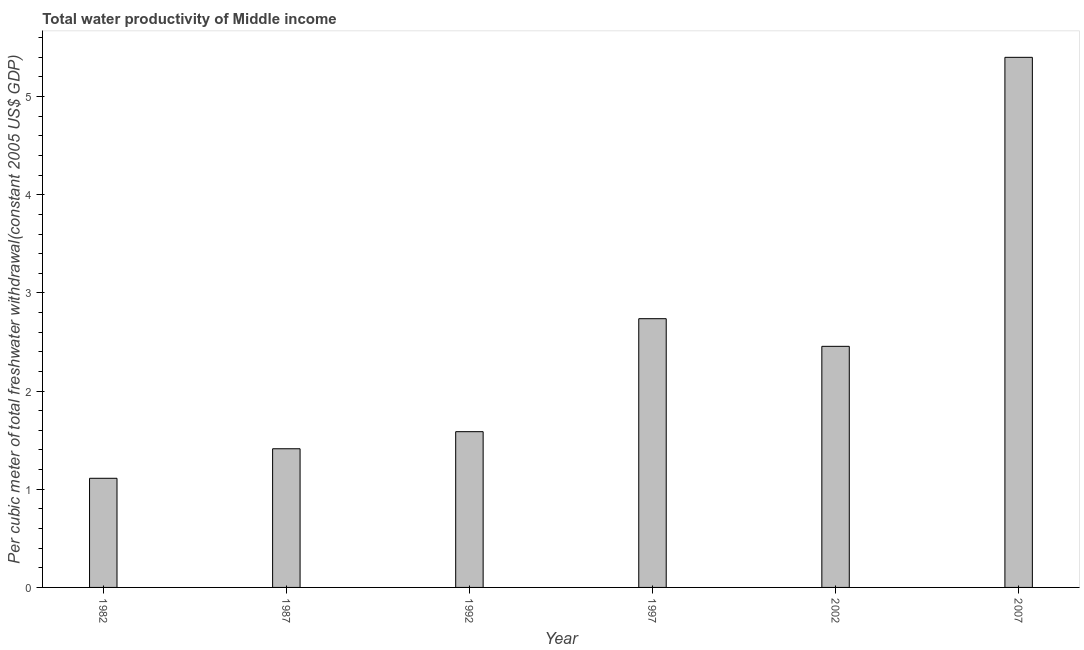Does the graph contain any zero values?
Your response must be concise. No. What is the title of the graph?
Your answer should be compact. Total water productivity of Middle income. What is the label or title of the Y-axis?
Provide a succinct answer. Per cubic meter of total freshwater withdrawal(constant 2005 US$ GDP). What is the total water productivity in 1992?
Give a very brief answer. 1.59. Across all years, what is the maximum total water productivity?
Ensure brevity in your answer.  5.4. Across all years, what is the minimum total water productivity?
Give a very brief answer. 1.11. In which year was the total water productivity maximum?
Keep it short and to the point. 2007. What is the sum of the total water productivity?
Ensure brevity in your answer.  14.7. What is the difference between the total water productivity in 1997 and 2002?
Keep it short and to the point. 0.28. What is the average total water productivity per year?
Your answer should be very brief. 2.45. What is the median total water productivity?
Provide a short and direct response. 2.02. What is the ratio of the total water productivity in 1982 to that in 2002?
Make the answer very short. 0.45. Is the total water productivity in 1982 less than that in 2007?
Your answer should be compact. Yes. What is the difference between the highest and the second highest total water productivity?
Make the answer very short. 2.66. Is the sum of the total water productivity in 1987 and 1997 greater than the maximum total water productivity across all years?
Provide a short and direct response. No. What is the difference between the highest and the lowest total water productivity?
Your answer should be compact. 4.29. Are all the bars in the graph horizontal?
Provide a succinct answer. No. Are the values on the major ticks of Y-axis written in scientific E-notation?
Give a very brief answer. No. What is the Per cubic meter of total freshwater withdrawal(constant 2005 US$ GDP) in 1982?
Offer a very short reply. 1.11. What is the Per cubic meter of total freshwater withdrawal(constant 2005 US$ GDP) of 1987?
Your answer should be compact. 1.41. What is the Per cubic meter of total freshwater withdrawal(constant 2005 US$ GDP) of 1992?
Offer a terse response. 1.59. What is the Per cubic meter of total freshwater withdrawal(constant 2005 US$ GDP) of 1997?
Your response must be concise. 2.74. What is the Per cubic meter of total freshwater withdrawal(constant 2005 US$ GDP) in 2002?
Provide a short and direct response. 2.46. What is the Per cubic meter of total freshwater withdrawal(constant 2005 US$ GDP) of 2007?
Provide a succinct answer. 5.4. What is the difference between the Per cubic meter of total freshwater withdrawal(constant 2005 US$ GDP) in 1982 and 1987?
Provide a short and direct response. -0.3. What is the difference between the Per cubic meter of total freshwater withdrawal(constant 2005 US$ GDP) in 1982 and 1992?
Make the answer very short. -0.47. What is the difference between the Per cubic meter of total freshwater withdrawal(constant 2005 US$ GDP) in 1982 and 1997?
Your answer should be very brief. -1.63. What is the difference between the Per cubic meter of total freshwater withdrawal(constant 2005 US$ GDP) in 1982 and 2002?
Your answer should be very brief. -1.34. What is the difference between the Per cubic meter of total freshwater withdrawal(constant 2005 US$ GDP) in 1982 and 2007?
Offer a terse response. -4.29. What is the difference between the Per cubic meter of total freshwater withdrawal(constant 2005 US$ GDP) in 1987 and 1992?
Provide a succinct answer. -0.17. What is the difference between the Per cubic meter of total freshwater withdrawal(constant 2005 US$ GDP) in 1987 and 1997?
Provide a succinct answer. -1.32. What is the difference between the Per cubic meter of total freshwater withdrawal(constant 2005 US$ GDP) in 1987 and 2002?
Ensure brevity in your answer.  -1.04. What is the difference between the Per cubic meter of total freshwater withdrawal(constant 2005 US$ GDP) in 1987 and 2007?
Your response must be concise. -3.99. What is the difference between the Per cubic meter of total freshwater withdrawal(constant 2005 US$ GDP) in 1992 and 1997?
Your answer should be compact. -1.15. What is the difference between the Per cubic meter of total freshwater withdrawal(constant 2005 US$ GDP) in 1992 and 2002?
Your answer should be very brief. -0.87. What is the difference between the Per cubic meter of total freshwater withdrawal(constant 2005 US$ GDP) in 1992 and 2007?
Your response must be concise. -3.81. What is the difference between the Per cubic meter of total freshwater withdrawal(constant 2005 US$ GDP) in 1997 and 2002?
Your answer should be very brief. 0.28. What is the difference between the Per cubic meter of total freshwater withdrawal(constant 2005 US$ GDP) in 1997 and 2007?
Your answer should be compact. -2.66. What is the difference between the Per cubic meter of total freshwater withdrawal(constant 2005 US$ GDP) in 2002 and 2007?
Keep it short and to the point. -2.94. What is the ratio of the Per cubic meter of total freshwater withdrawal(constant 2005 US$ GDP) in 1982 to that in 1987?
Make the answer very short. 0.79. What is the ratio of the Per cubic meter of total freshwater withdrawal(constant 2005 US$ GDP) in 1982 to that in 1992?
Ensure brevity in your answer.  0.7. What is the ratio of the Per cubic meter of total freshwater withdrawal(constant 2005 US$ GDP) in 1982 to that in 1997?
Your answer should be very brief. 0.41. What is the ratio of the Per cubic meter of total freshwater withdrawal(constant 2005 US$ GDP) in 1982 to that in 2002?
Offer a very short reply. 0.45. What is the ratio of the Per cubic meter of total freshwater withdrawal(constant 2005 US$ GDP) in 1982 to that in 2007?
Provide a short and direct response. 0.21. What is the ratio of the Per cubic meter of total freshwater withdrawal(constant 2005 US$ GDP) in 1987 to that in 1992?
Provide a short and direct response. 0.89. What is the ratio of the Per cubic meter of total freshwater withdrawal(constant 2005 US$ GDP) in 1987 to that in 1997?
Offer a very short reply. 0.52. What is the ratio of the Per cubic meter of total freshwater withdrawal(constant 2005 US$ GDP) in 1987 to that in 2002?
Make the answer very short. 0.57. What is the ratio of the Per cubic meter of total freshwater withdrawal(constant 2005 US$ GDP) in 1987 to that in 2007?
Your answer should be compact. 0.26. What is the ratio of the Per cubic meter of total freshwater withdrawal(constant 2005 US$ GDP) in 1992 to that in 1997?
Provide a short and direct response. 0.58. What is the ratio of the Per cubic meter of total freshwater withdrawal(constant 2005 US$ GDP) in 1992 to that in 2002?
Provide a short and direct response. 0.65. What is the ratio of the Per cubic meter of total freshwater withdrawal(constant 2005 US$ GDP) in 1992 to that in 2007?
Keep it short and to the point. 0.29. What is the ratio of the Per cubic meter of total freshwater withdrawal(constant 2005 US$ GDP) in 1997 to that in 2002?
Your response must be concise. 1.11. What is the ratio of the Per cubic meter of total freshwater withdrawal(constant 2005 US$ GDP) in 1997 to that in 2007?
Keep it short and to the point. 0.51. What is the ratio of the Per cubic meter of total freshwater withdrawal(constant 2005 US$ GDP) in 2002 to that in 2007?
Offer a very short reply. 0.46. 